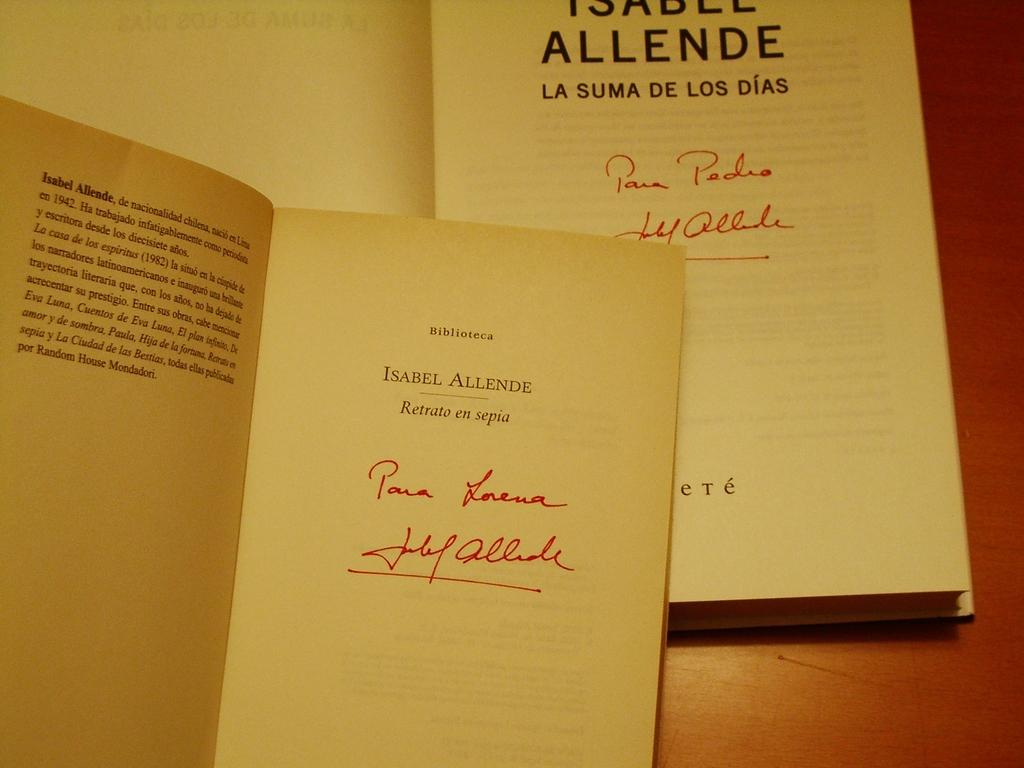<image>
Summarize the visual content of the image. Two books written by Isabel Allende are open to their front page. 